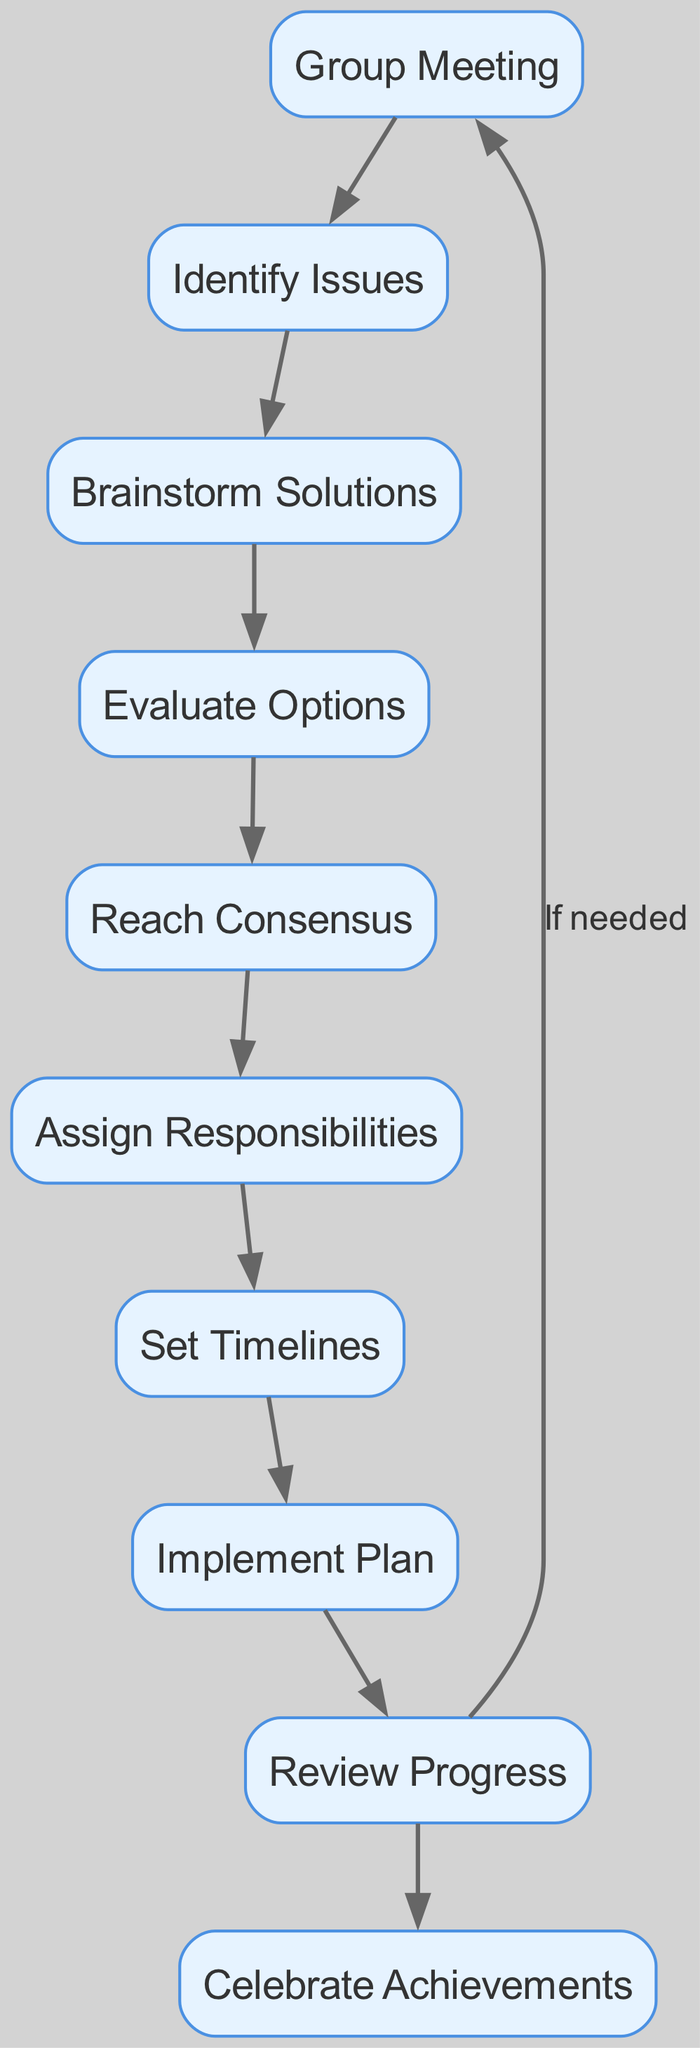What is the first step in the decision-making process? The diagram indicates that the first step is "Group Meeting," which is the starting node in the flowchart.
Answer: Group Meeting How many nodes are there in total? By counting the distinct items listed as nodes in the diagram, we find there are ten nodes.
Answer: 10 What comes after "Brainstorm Solutions"? The diagram shows that "Evaluate Options" follows next after "Brainstorm Solutions," making it the subsequent step in the process.
Answer: Evaluate Options What is the final step in the process? The last step as illustrated in the diagram is "Celebrate Achievements," which concludes the decision-making process.
Answer: Celebrate Achievements Which step leads back to the "Group Meeting"? According to the diagram, the step "Review Progress" has a directed edge that points back to "Group Meeting," indicating a loop in the process when needed.
Answer: Review Progress What do "Assign Responsibilities" and "Set Timelines" have in common? Both steps directly follow each other in the process, with "Assign Responsibilities" leading to "Set Timelines," indicating they are sequential in the flow.
Answer: Sequential steps How many edges are present in the diagram? To determine the number of edges, we can count all the connections or direct paths between the nodes, which total to nine edges in the diagram.
Answer: 9 What is required before "Implement Plan"? The diagram highlights that "Set Timelines" must be completed before proceeding to "Implement Plan," making it a prerequisite step.
Answer: Set Timelines How many edges connect to "Review Progress"? Analyzing the diagram, we see that there are two edges connected to "Review Progress," one leading to "Celebrate Achievements" and one leading back to "Group Meeting."
Answer: 2 Which step is the third in the process? By following the directed flow from the beginning, we observe that "Evaluate Options" is the third step after "Group Meeting" and "Identify Issues."
Answer: Evaluate Options 